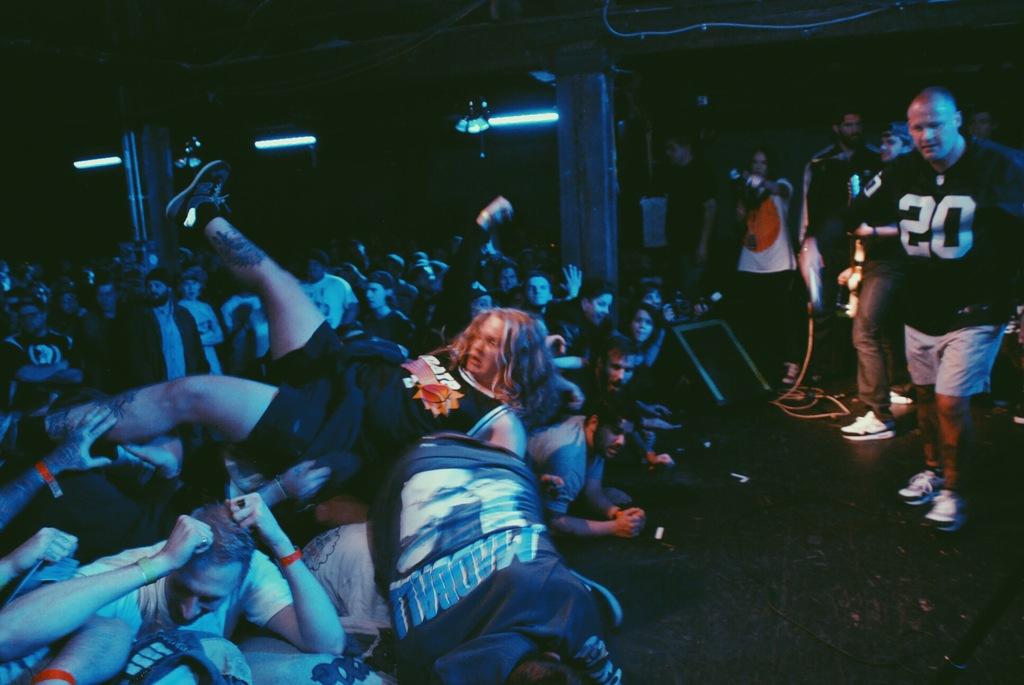What number is on the bald man's tshirt?
Ensure brevity in your answer.  20. What word is on the man who is upside down in front?
Ensure brevity in your answer.  Madball. 